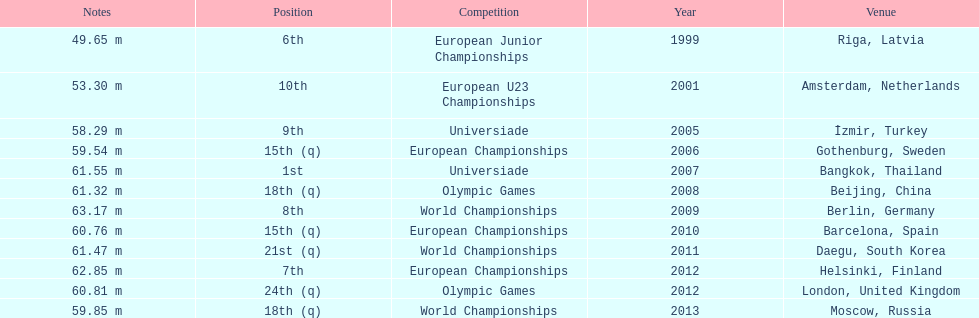Which competitions has gerhard mayer competed in since 1999? European Junior Championships, European U23 Championships, Universiade, European Championships, Universiade, Olympic Games, World Championships, European Championships, World Championships, European Championships, Olympic Games, World Championships. Of these competition, in which ones did he throw at least 60 m? Universiade, Olympic Games, World Championships, European Championships, World Championships, European Championships, Olympic Games. Of these throws, which was his longest? 63.17 m. 